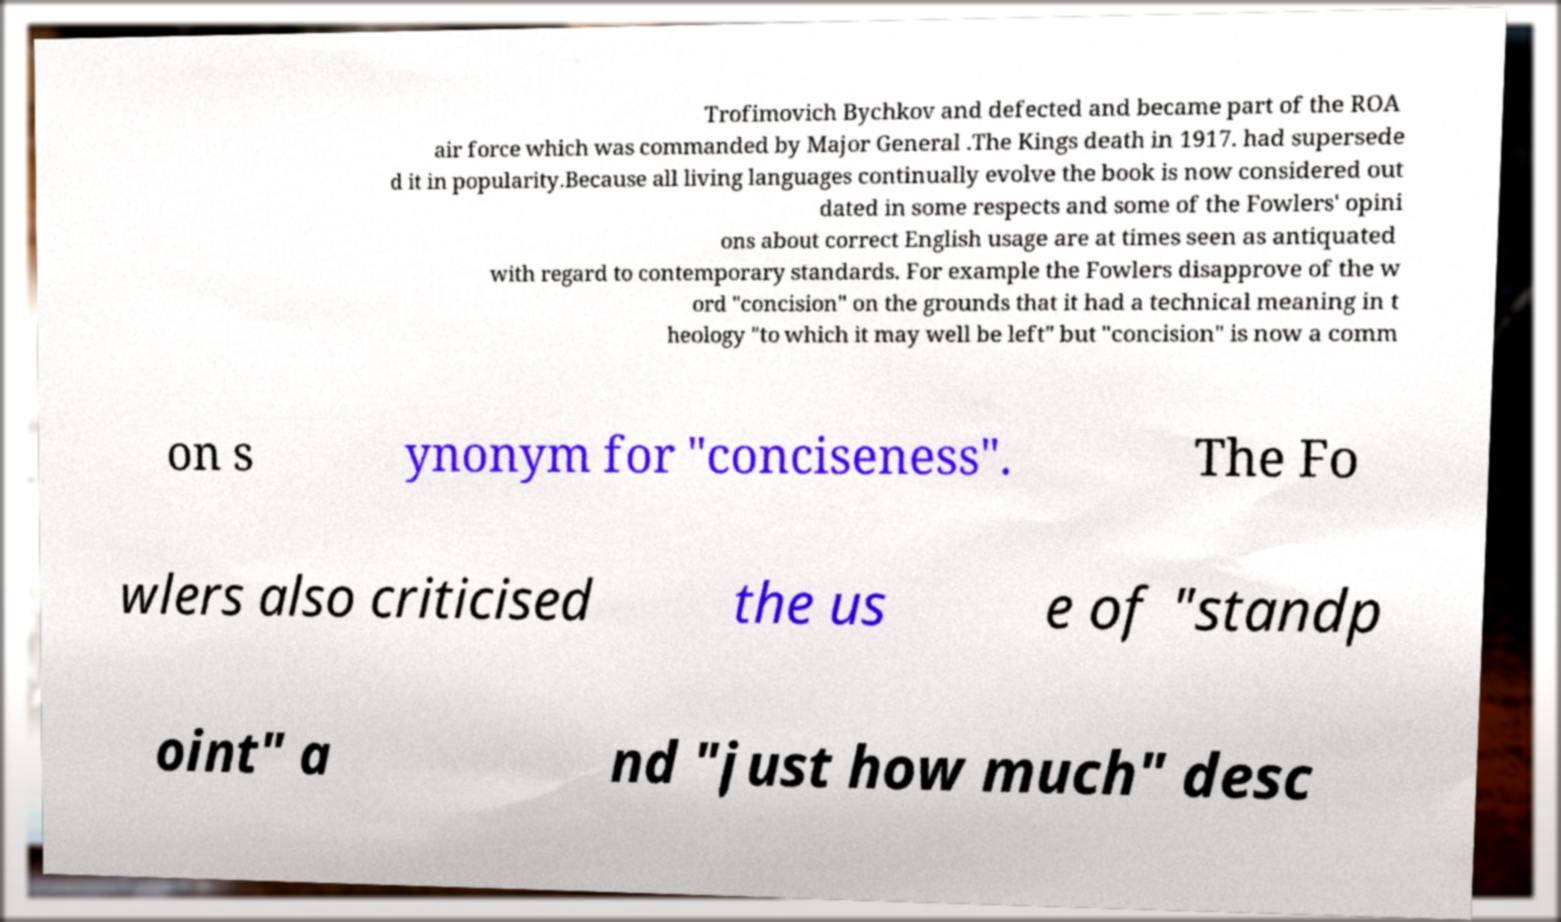There's text embedded in this image that I need extracted. Can you transcribe it verbatim? Trofimovich Bychkov and defected and became part of the ROA air force which was commanded by Major General .The Kings death in 1917. had supersede d it in popularity.Because all living languages continually evolve the book is now considered out dated in some respects and some of the Fowlers' opini ons about correct English usage are at times seen as antiquated with regard to contemporary standards. For example the Fowlers disapprove of the w ord "concision" on the grounds that it had a technical meaning in t heology "to which it may well be left" but "concision" is now a comm on s ynonym for "conciseness". The Fo wlers also criticised the us e of "standp oint" a nd "just how much" desc 